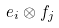Convert formula to latex. <formula><loc_0><loc_0><loc_500><loc_500>e _ { i } \otimes f _ { j }</formula> 